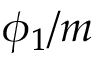<formula> <loc_0><loc_0><loc_500><loc_500>\phi _ { 1 } / m</formula> 